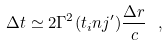Convert formula to latex. <formula><loc_0><loc_0><loc_500><loc_500>\Delta t \simeq 2 \Gamma ^ { 2 } ( t _ { i } n j ^ { \prime } ) \frac { \Delta r } { c } \ ,</formula> 